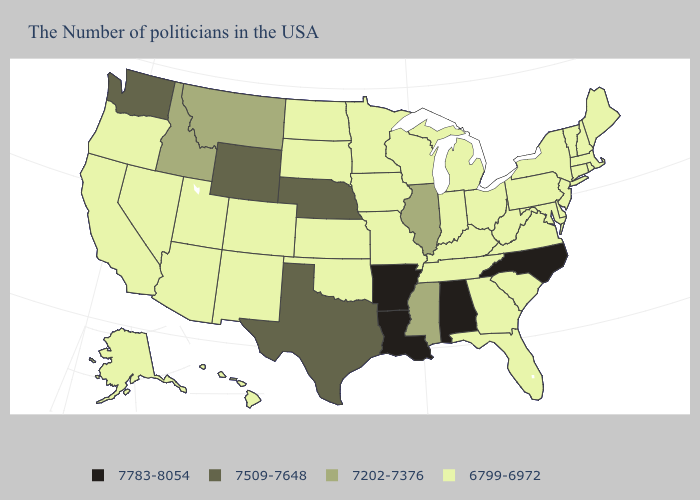What is the lowest value in states that border Wisconsin?
Be succinct. 6799-6972. Name the states that have a value in the range 7509-7648?
Give a very brief answer. Nebraska, Texas, Wyoming, Washington. Which states hav the highest value in the Northeast?
Keep it brief. Maine, Massachusetts, Rhode Island, New Hampshire, Vermont, Connecticut, New York, New Jersey, Pennsylvania. Name the states that have a value in the range 7509-7648?
Give a very brief answer. Nebraska, Texas, Wyoming, Washington. What is the value of Missouri?
Concise answer only. 6799-6972. Does Oklahoma have the same value as Wyoming?
Concise answer only. No. What is the value of Wyoming?
Be succinct. 7509-7648. What is the value of Ohio?
Be succinct. 6799-6972. What is the highest value in the USA?
Keep it brief. 7783-8054. Does Virginia have the lowest value in the USA?
Give a very brief answer. Yes. Does Alabama have the lowest value in the South?
Write a very short answer. No. What is the lowest value in the Northeast?
Concise answer only. 6799-6972. Does Colorado have the lowest value in the USA?
Quick response, please. Yes. What is the value of Delaware?
Quick response, please. 6799-6972. Name the states that have a value in the range 6799-6972?
Concise answer only. Maine, Massachusetts, Rhode Island, New Hampshire, Vermont, Connecticut, New York, New Jersey, Delaware, Maryland, Pennsylvania, Virginia, South Carolina, West Virginia, Ohio, Florida, Georgia, Michigan, Kentucky, Indiana, Tennessee, Wisconsin, Missouri, Minnesota, Iowa, Kansas, Oklahoma, South Dakota, North Dakota, Colorado, New Mexico, Utah, Arizona, Nevada, California, Oregon, Alaska, Hawaii. 